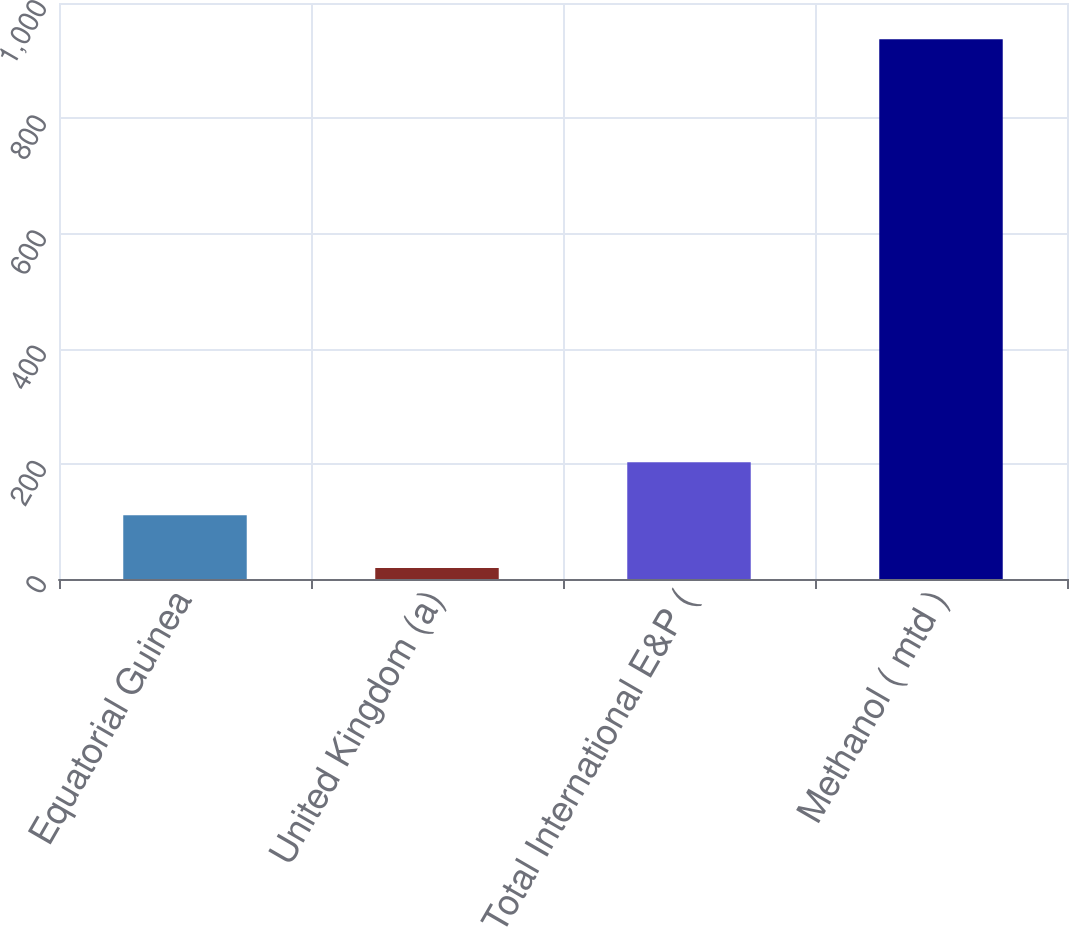Convert chart to OTSL. <chart><loc_0><loc_0><loc_500><loc_500><bar_chart><fcel>Equatorial Guinea<fcel>United Kingdom (a)<fcel>Total International E&P (<fcel>Methanol ( mtd )<nl><fcel>110.8<fcel>19<fcel>202.6<fcel>937<nl></chart> 